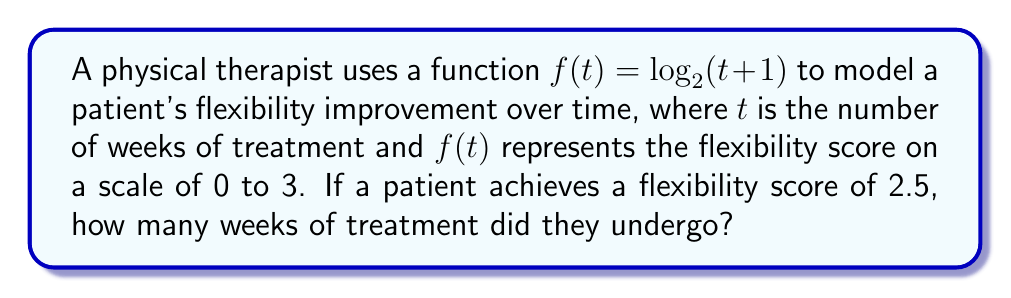Show me your answer to this math problem. To solve this problem, we need to find the inverse function of $f(t)$ and then evaluate it at 2.5. Let's follow these steps:

1) The given function is $f(t) = \log_2(t+1)$

2) To find the inverse function, we first replace $f(t)$ with $y$:
   $y = \log_2(t+1)$

3) Now, we swap $y$ and $t$:
   $t = \log_2(y+1)$

4) To solve for $y$, we apply $2^x$ to both sides:
   $2^t = 2^{\log_2(y+1)}$

5) The right side simplifies due to the properties of logarithms:
   $2^t = y+1$

6) Subtract 1 from both sides:
   $2^t - 1 = y$

7) Therefore, the inverse function is:
   $f^{-1}(t) = 2^t - 1$

8) Now, we need to evaluate $f^{-1}(2.5)$:
   $f^{-1}(2.5) = 2^{2.5} - 1$

9) Calculate $2^{2.5}$:
   $2^{2.5} \approx 5.6569$

10) Subtract 1:
    $5.6569 - 1 = 4.6569$

Therefore, the patient underwent approximately 4.6569 weeks of treatment.
Answer: $4.6569$ weeks 